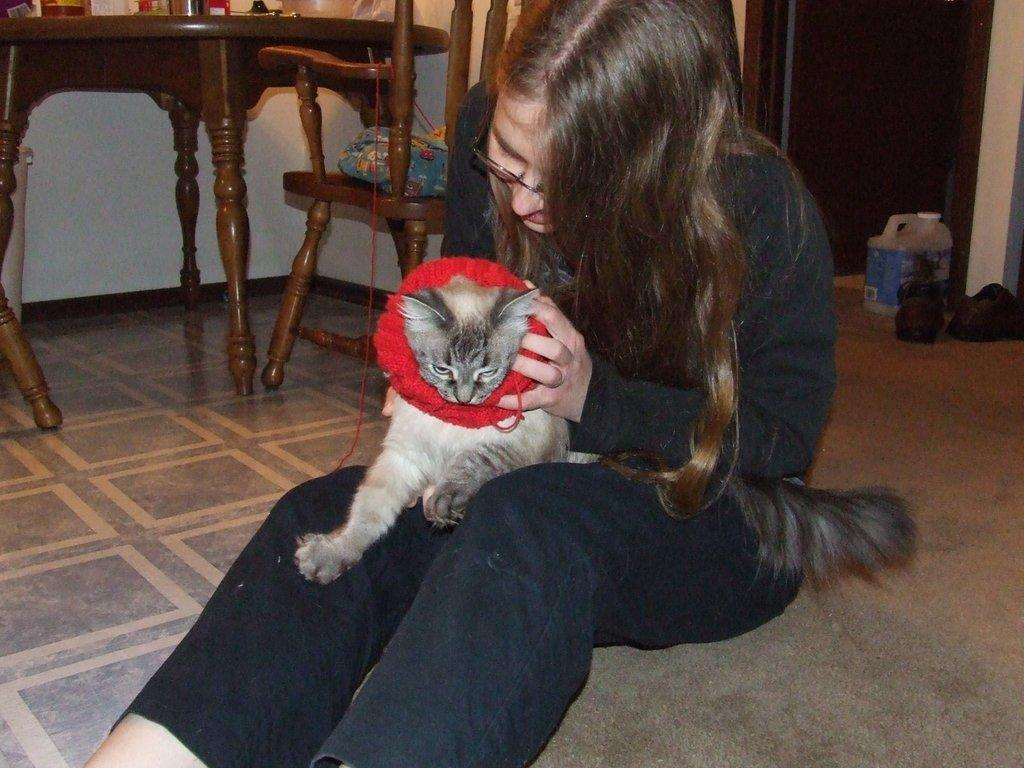What is the woman in the image doing? The woman is seated on the floor in the image. What is the woman holding in her hand? The woman is holding a cat in her hand. What type of furniture is present in the image? There is a dining table and chairs near the dining table in the image. What type of bun is the woman wearing in the image? There is no mention of a bun in the image, and the woman is not wearing any headwear. 